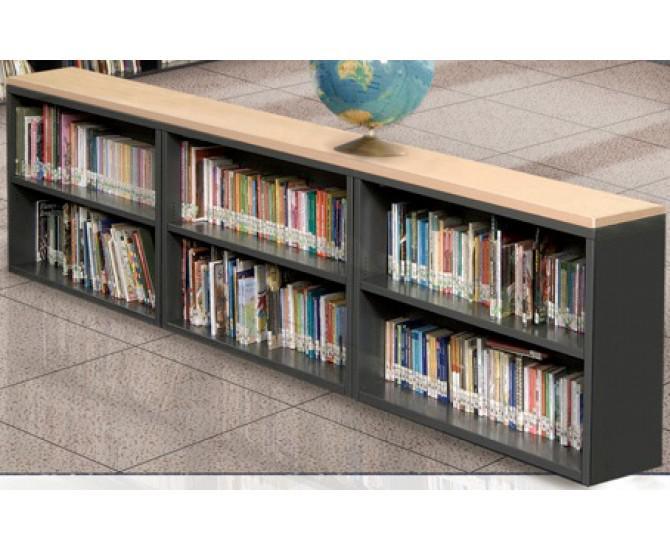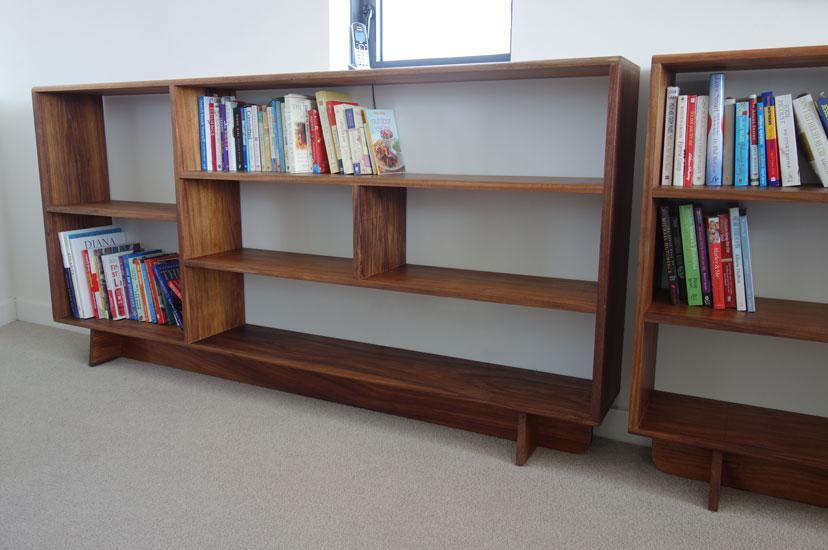The first image is the image on the left, the second image is the image on the right. For the images displayed, is the sentence "The bookshelf in the image on the left is sitting against a white wall." factually correct? Answer yes or no. No. The first image is the image on the left, the second image is the image on the right. For the images shown, is this caption "At least one image shows a white low bookshelf unit that sits flush on the ground and has a variety of items displayed on its top." true? Answer yes or no. No. 